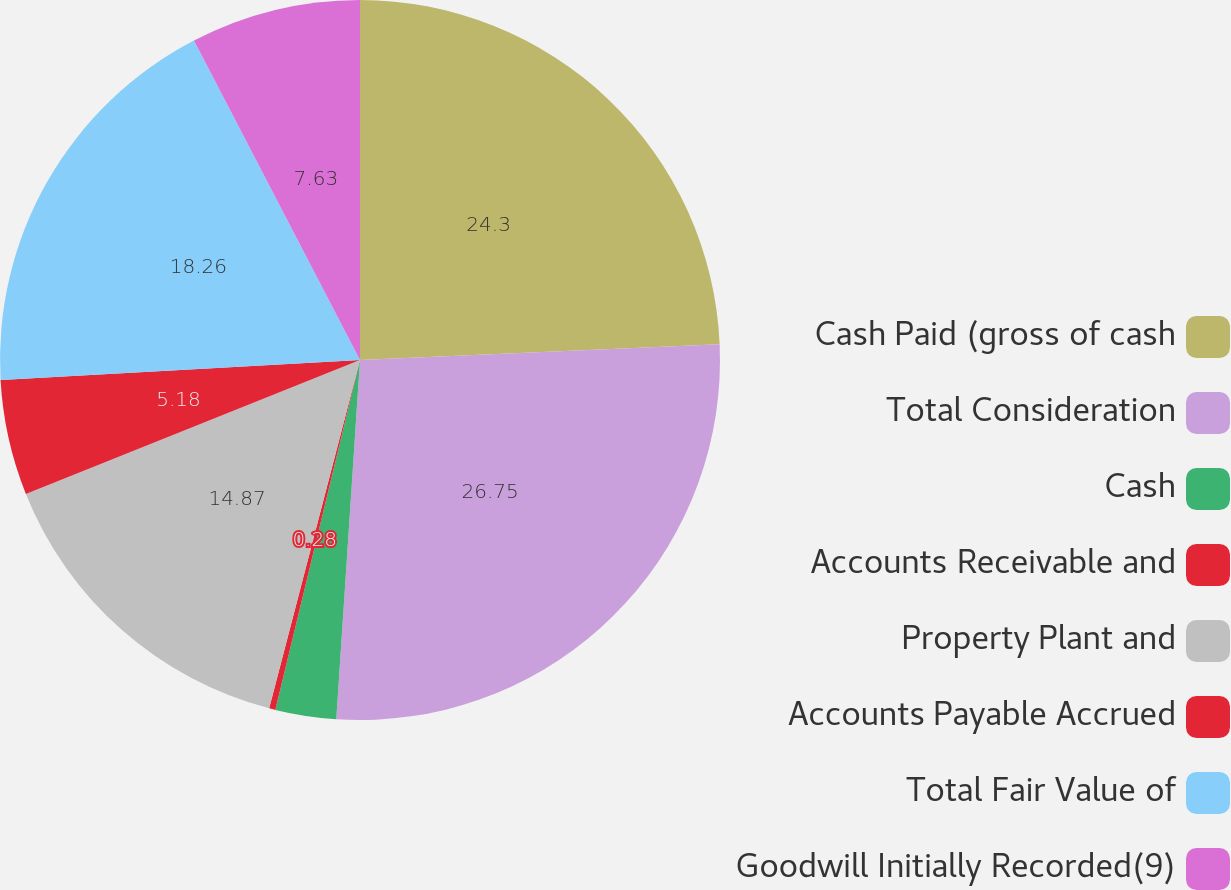Convert chart to OTSL. <chart><loc_0><loc_0><loc_500><loc_500><pie_chart><fcel>Cash Paid (gross of cash<fcel>Total Consideration<fcel>Cash<fcel>Accounts Receivable and<fcel>Property Plant and<fcel>Accounts Payable Accrued<fcel>Total Fair Value of<fcel>Goodwill Initially Recorded(9)<nl><fcel>24.3%<fcel>26.75%<fcel>2.73%<fcel>0.28%<fcel>14.87%<fcel>5.18%<fcel>18.26%<fcel>7.63%<nl></chart> 